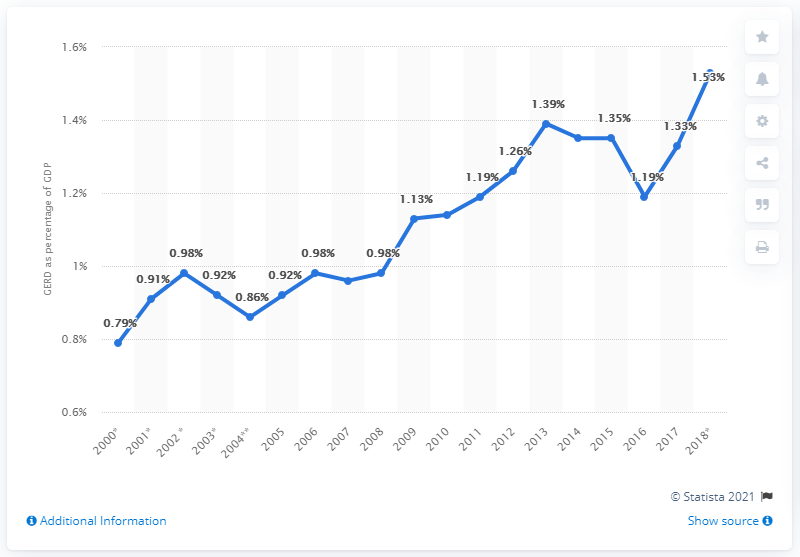Indicate a few pertinent items in this graphic. In 2015, the share of GERD in Hungary's GDP was 1.39%. 